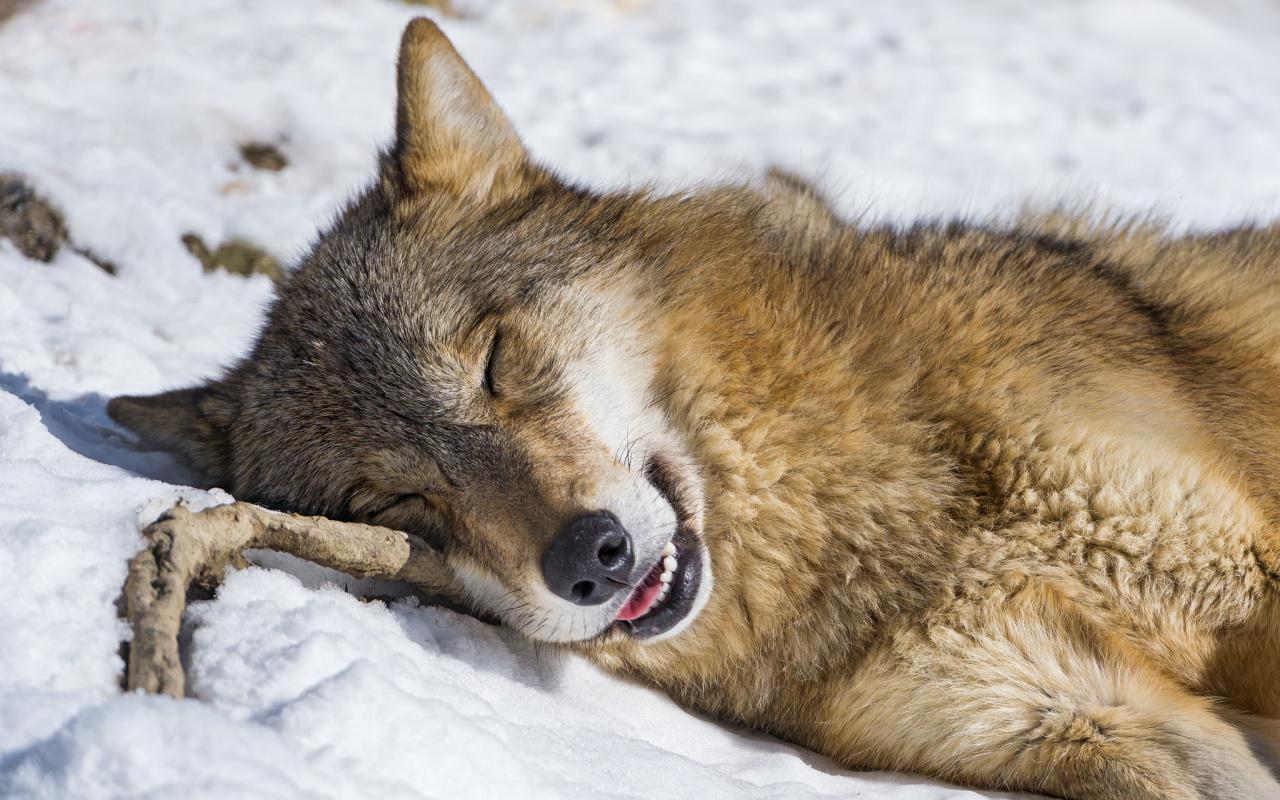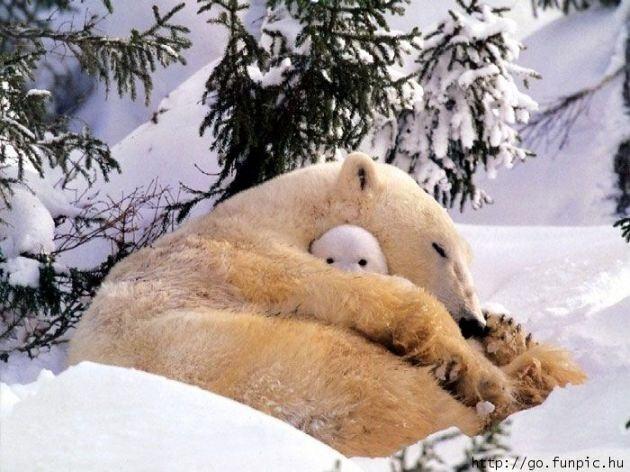The first image is the image on the left, the second image is the image on the right. Considering the images on both sides, is "A single wolf is pictured sleeping in one of the images." valid? Answer yes or no. Yes. 